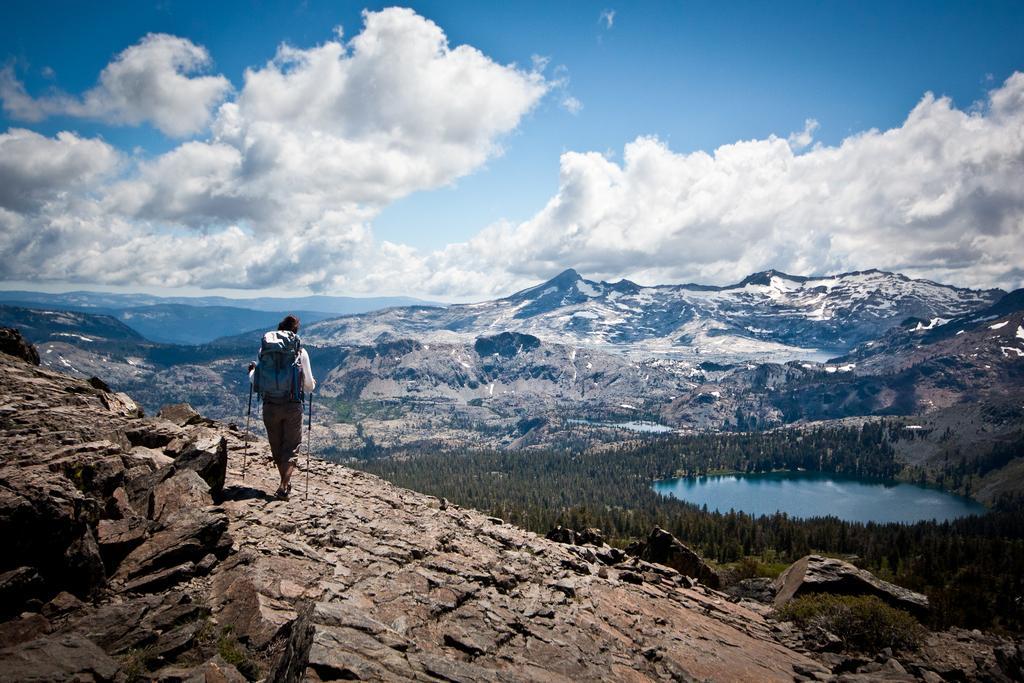In one or two sentences, can you explain what this image depicts? In this image, we can see a person is wearing a backpack and walking on the hill. Here we can see few rocks and plants. Background we can see hills, tees, water and cloudy sky. 